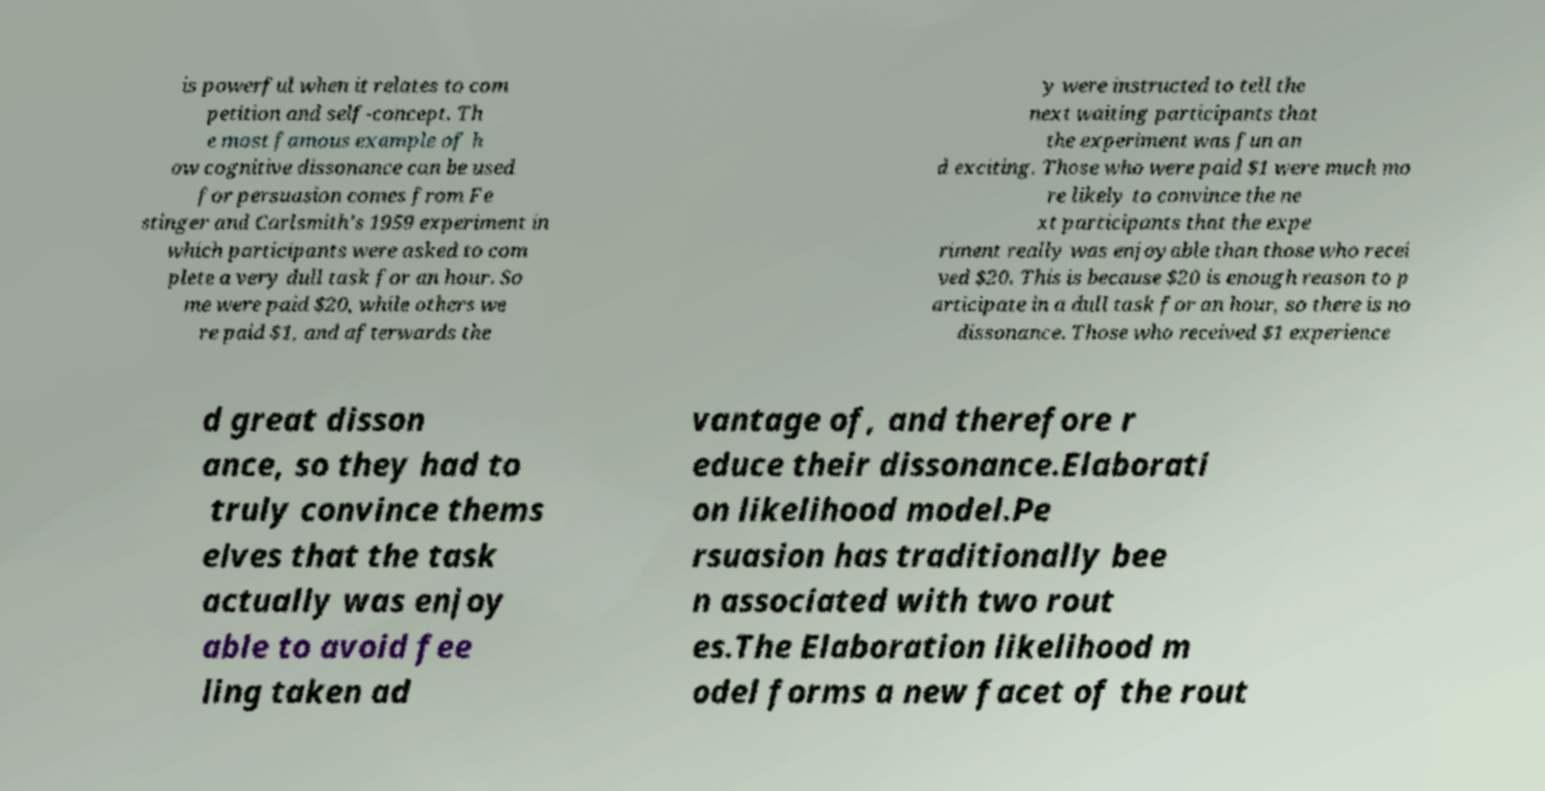Can you accurately transcribe the text from the provided image for me? is powerful when it relates to com petition and self-concept. Th e most famous example of h ow cognitive dissonance can be used for persuasion comes from Fe stinger and Carlsmith's 1959 experiment in which participants were asked to com plete a very dull task for an hour. So me were paid $20, while others we re paid $1, and afterwards the y were instructed to tell the next waiting participants that the experiment was fun an d exciting. Those who were paid $1 were much mo re likely to convince the ne xt participants that the expe riment really was enjoyable than those who recei ved $20. This is because $20 is enough reason to p articipate in a dull task for an hour, so there is no dissonance. Those who received $1 experience d great disson ance, so they had to truly convince thems elves that the task actually was enjoy able to avoid fee ling taken ad vantage of, and therefore r educe their dissonance.Elaborati on likelihood model.Pe rsuasion has traditionally bee n associated with two rout es.The Elaboration likelihood m odel forms a new facet of the rout 